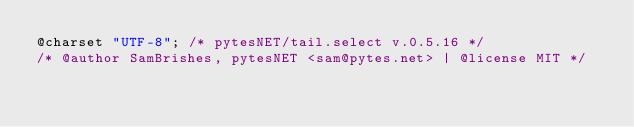Convert code to text. <code><loc_0><loc_0><loc_500><loc_500><_CSS_>@charset "UTF-8"; /* pytesNET/tail.select v.0.5.16 */
/* @author SamBrishes, pytesNET <sam@pytes.net> | @license MIT */</code> 